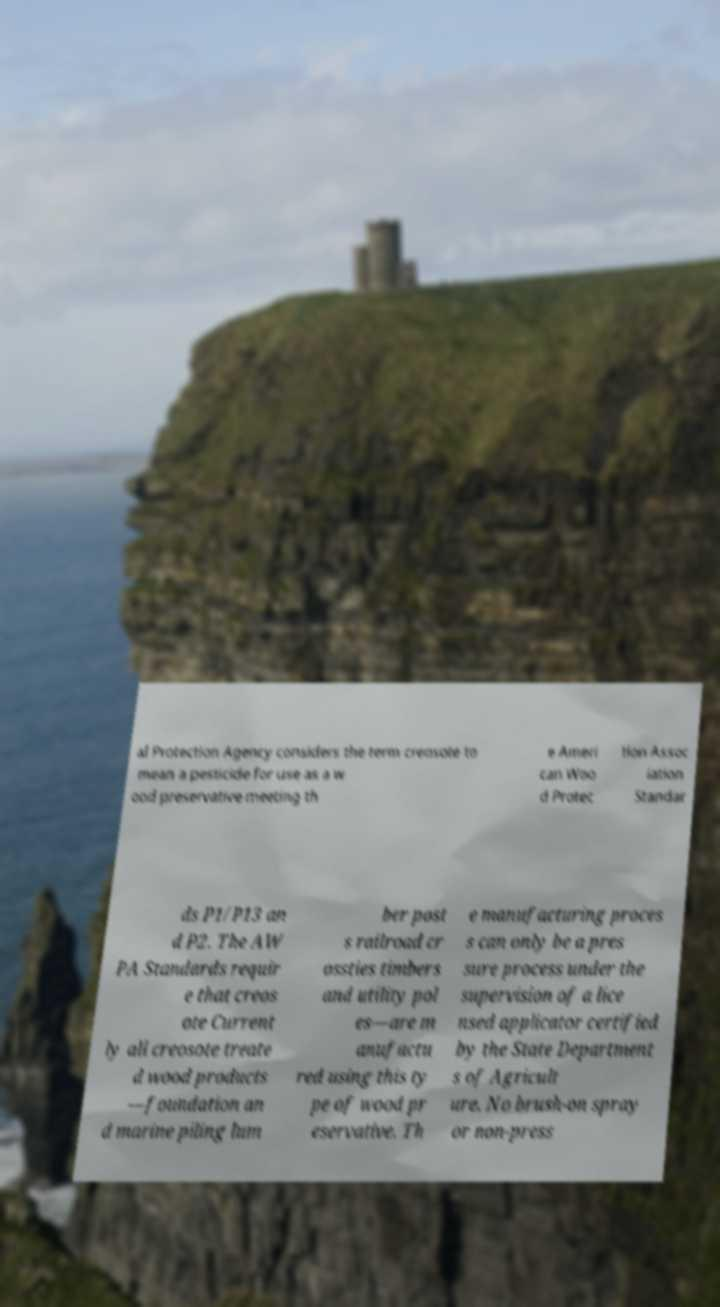There's text embedded in this image that I need extracted. Can you transcribe it verbatim? al Protection Agency considers the term creosote to mean a pesticide for use as a w ood preservative meeting th e Ameri can Woo d Protec tion Assoc iation Standar ds P1/P13 an d P2. The AW PA Standards requir e that creos ote Current ly all creosote treate d wood products —foundation an d marine piling lum ber post s railroad cr ossties timbers and utility pol es—are m anufactu red using this ty pe of wood pr eservative. Th e manufacturing proces s can only be a pres sure process under the supervision of a lice nsed applicator certified by the State Department s of Agricult ure. No brush-on spray or non-press 